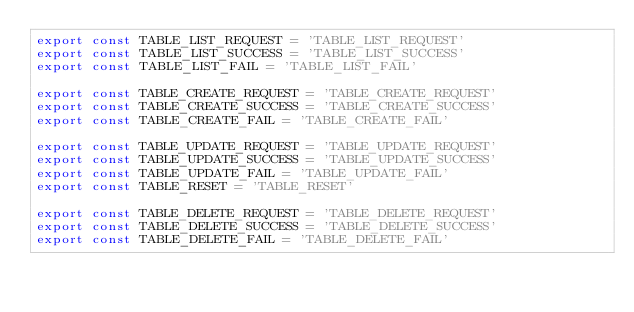Convert code to text. <code><loc_0><loc_0><loc_500><loc_500><_JavaScript_>export const TABLE_LIST_REQUEST = 'TABLE_LIST_REQUEST'
export const TABLE_LIST_SUCCESS = 'TABLE_LIST_SUCCESS'
export const TABLE_LIST_FAIL = 'TABLE_LIST_FAIL'

export const TABLE_CREATE_REQUEST = 'TABLE_CREATE_REQUEST'
export const TABLE_CREATE_SUCCESS = 'TABLE_CREATE_SUCCESS'
export const TABLE_CREATE_FAIL = 'TABLE_CREATE_FAIL'

export const TABLE_UPDATE_REQUEST = 'TABLE_UPDATE_REQUEST'
export const TABLE_UPDATE_SUCCESS = 'TABLE_UPDATE_SUCCESS'
export const TABLE_UPDATE_FAIL = 'TABLE_UPDATE_FAIL'
export const TABLE_RESET = 'TABLE_RESET'

export const TABLE_DELETE_REQUEST = 'TABLE_DELETE_REQUEST'
export const TABLE_DELETE_SUCCESS = 'TABLE_DELETE_SUCCESS'
export const TABLE_DELETE_FAIL = 'TABLE_DELETE_FAIL'
</code> 